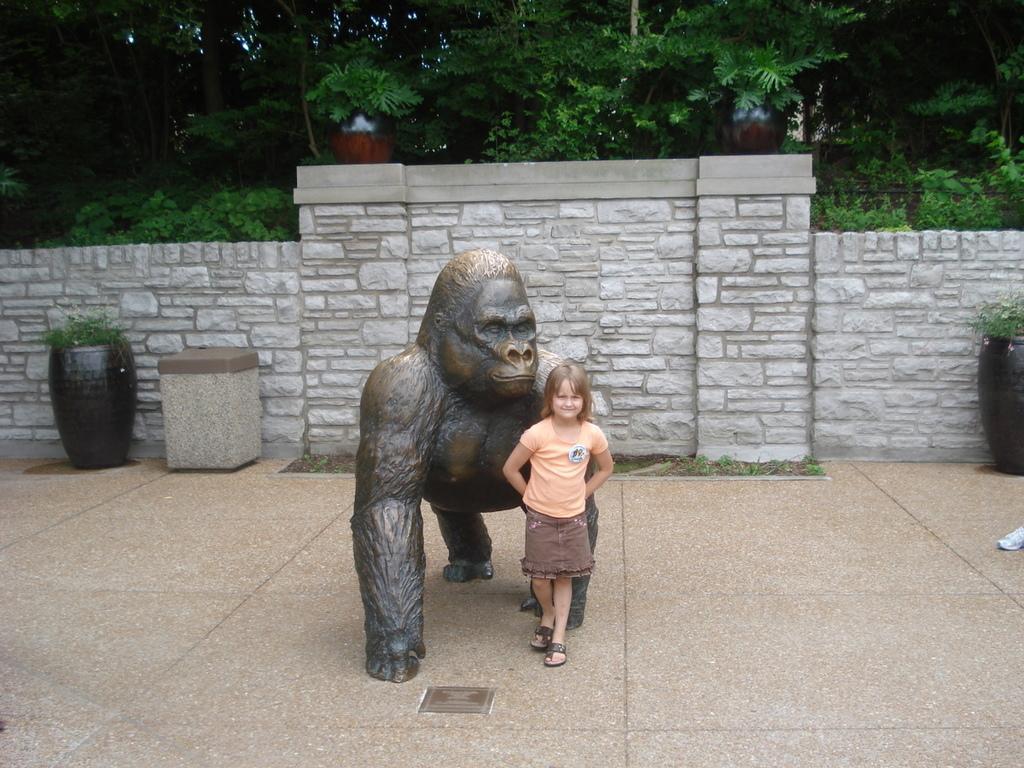Describe this image in one or two sentences. In the center of the image we can see a girl standing and there is a sculpture. In the background there is a wall and we can see plants. There are trees. 